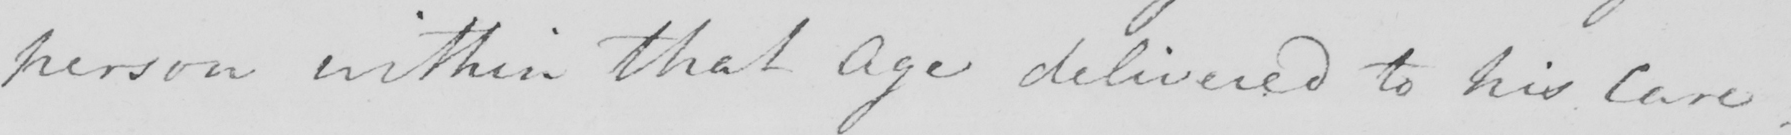Can you read and transcribe this handwriting? person within that Age delivered to his Care  . 